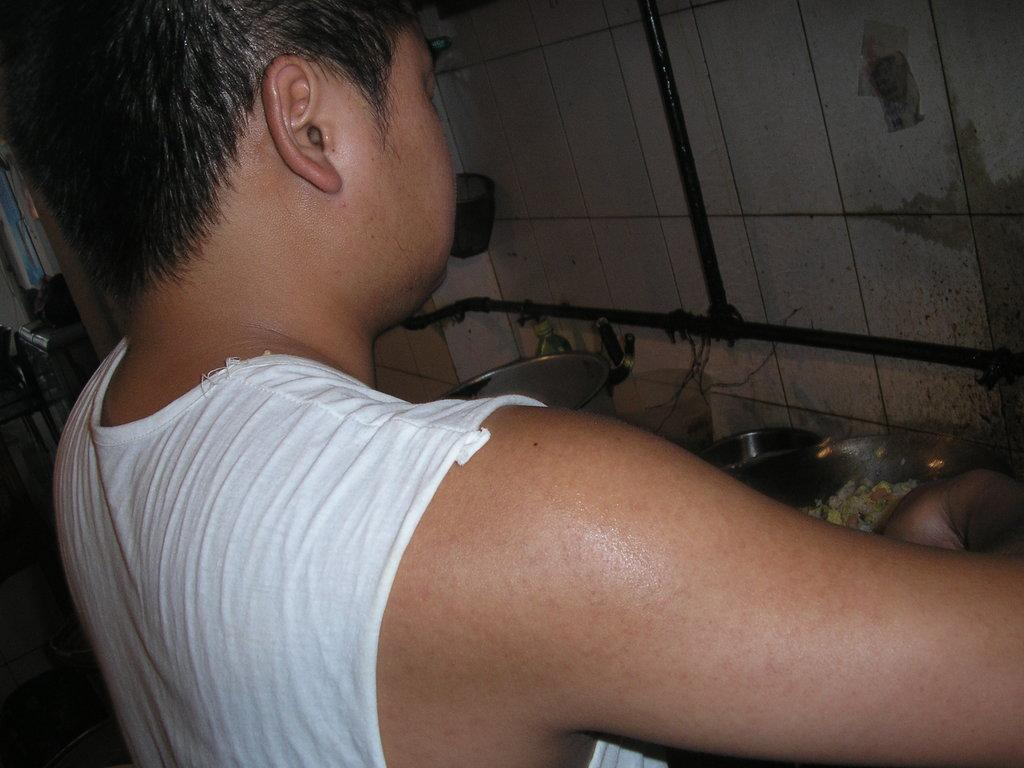What is the person in the image wearing? The person is wearing a white banyan in the image. What is the person doing in the image? The person is standing in the image. What is located near the person? There is a table in the image. What can be found on the table? Vessels are present on the table. What else is visible in the image? Pipes are visible in the image. Where are the pipes attached? The pipes are attached to a white wall in the image. What type of cactus can be seen growing on the wall in the image? There is no cactus present in the image; it features a person in a white banyan, a table with vessels, and pipes attached to a white wall. 